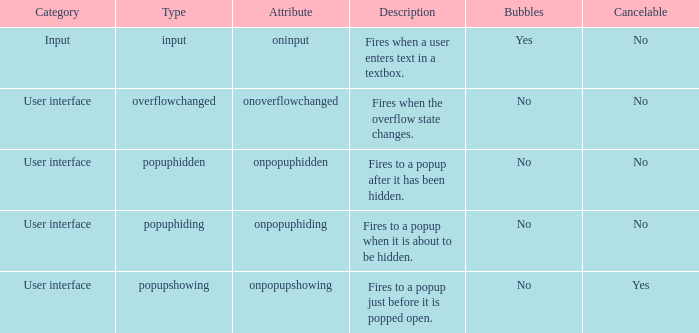In how many bubbles is the category considered input? 1.0. 